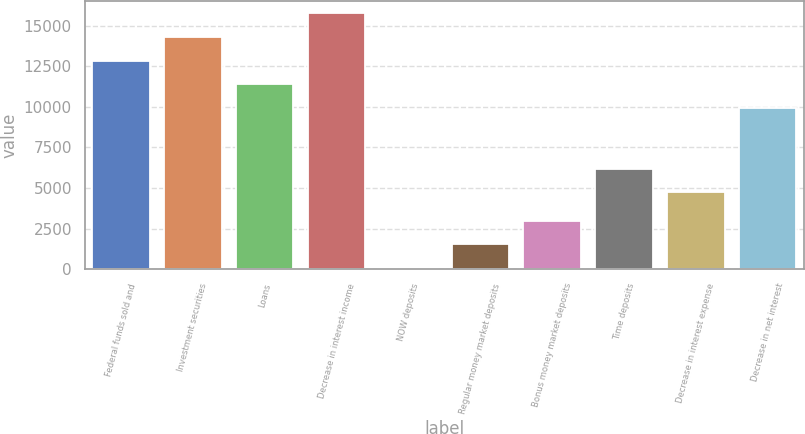Convert chart to OTSL. <chart><loc_0><loc_0><loc_500><loc_500><bar_chart><fcel>Federal funds sold and<fcel>Investment securities<fcel>Loans<fcel>Decrease in interest income<fcel>NOW deposits<fcel>Regular money market deposits<fcel>Bonus money market deposits<fcel>Time deposits<fcel>Decrease in interest expense<fcel>Decrease in net interest<nl><fcel>12845.4<fcel>14299.8<fcel>11391<fcel>15754.2<fcel>69<fcel>1523.4<fcel>2977.8<fcel>6173.4<fcel>4719<fcel>9894<nl></chart> 